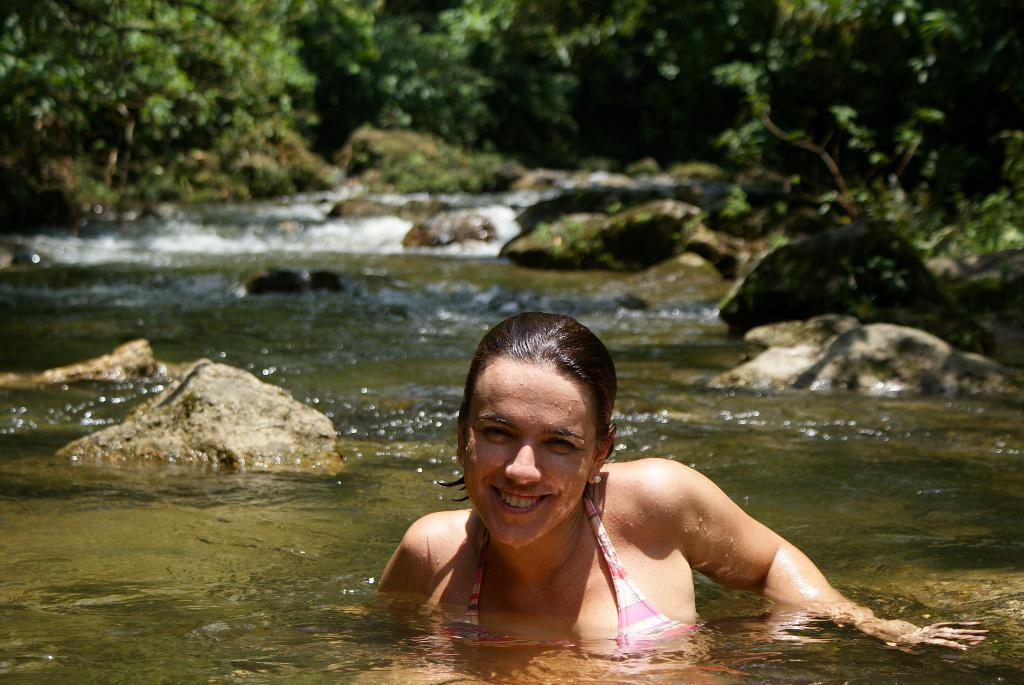Who is the main subject in the image? There is a girl in the image. What is the girl doing in the image? The girl is in the water. What can be seen in the background of the image? There are rocks and trees in the background of the image. What type of pain is the girl experiencing in the image? There is no indication of pain in the image, so it cannot be determined from the picture. 